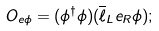Convert formula to latex. <formula><loc_0><loc_0><loc_500><loc_500>O _ { e \phi } = ( \phi ^ { \dagger } \phi ) ( \overline { \ell } _ { L } e _ { R } \phi ) ;</formula> 